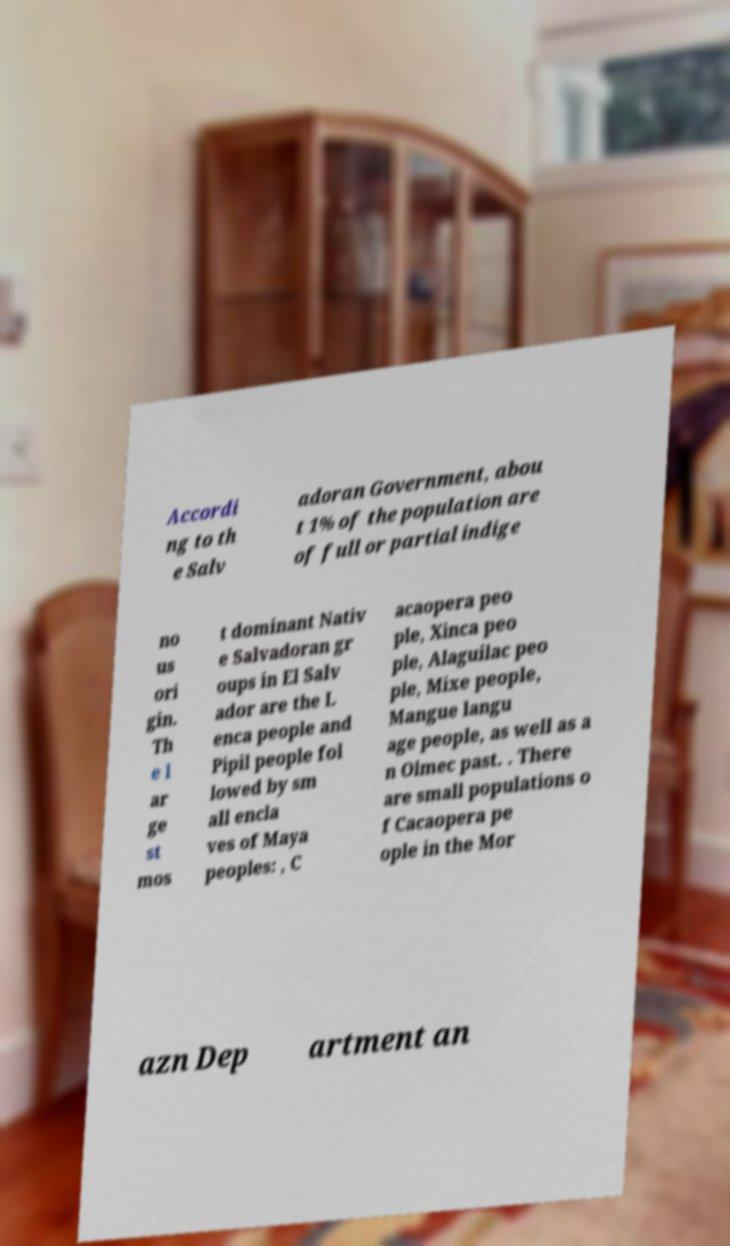There's text embedded in this image that I need extracted. Can you transcribe it verbatim? Accordi ng to th e Salv adoran Government, abou t 1% of the population are of full or partial indige no us ori gin. Th e l ar ge st mos t dominant Nativ e Salvadoran gr oups in El Salv ador are the L enca people and Pipil people fol lowed by sm all encla ves of Maya peoples: , C acaopera peo ple, Xinca peo ple, Alaguilac peo ple, Mixe people, Mangue langu age people, as well as a n Olmec past. . There are small populations o f Cacaopera pe ople in the Mor azn Dep artment an 